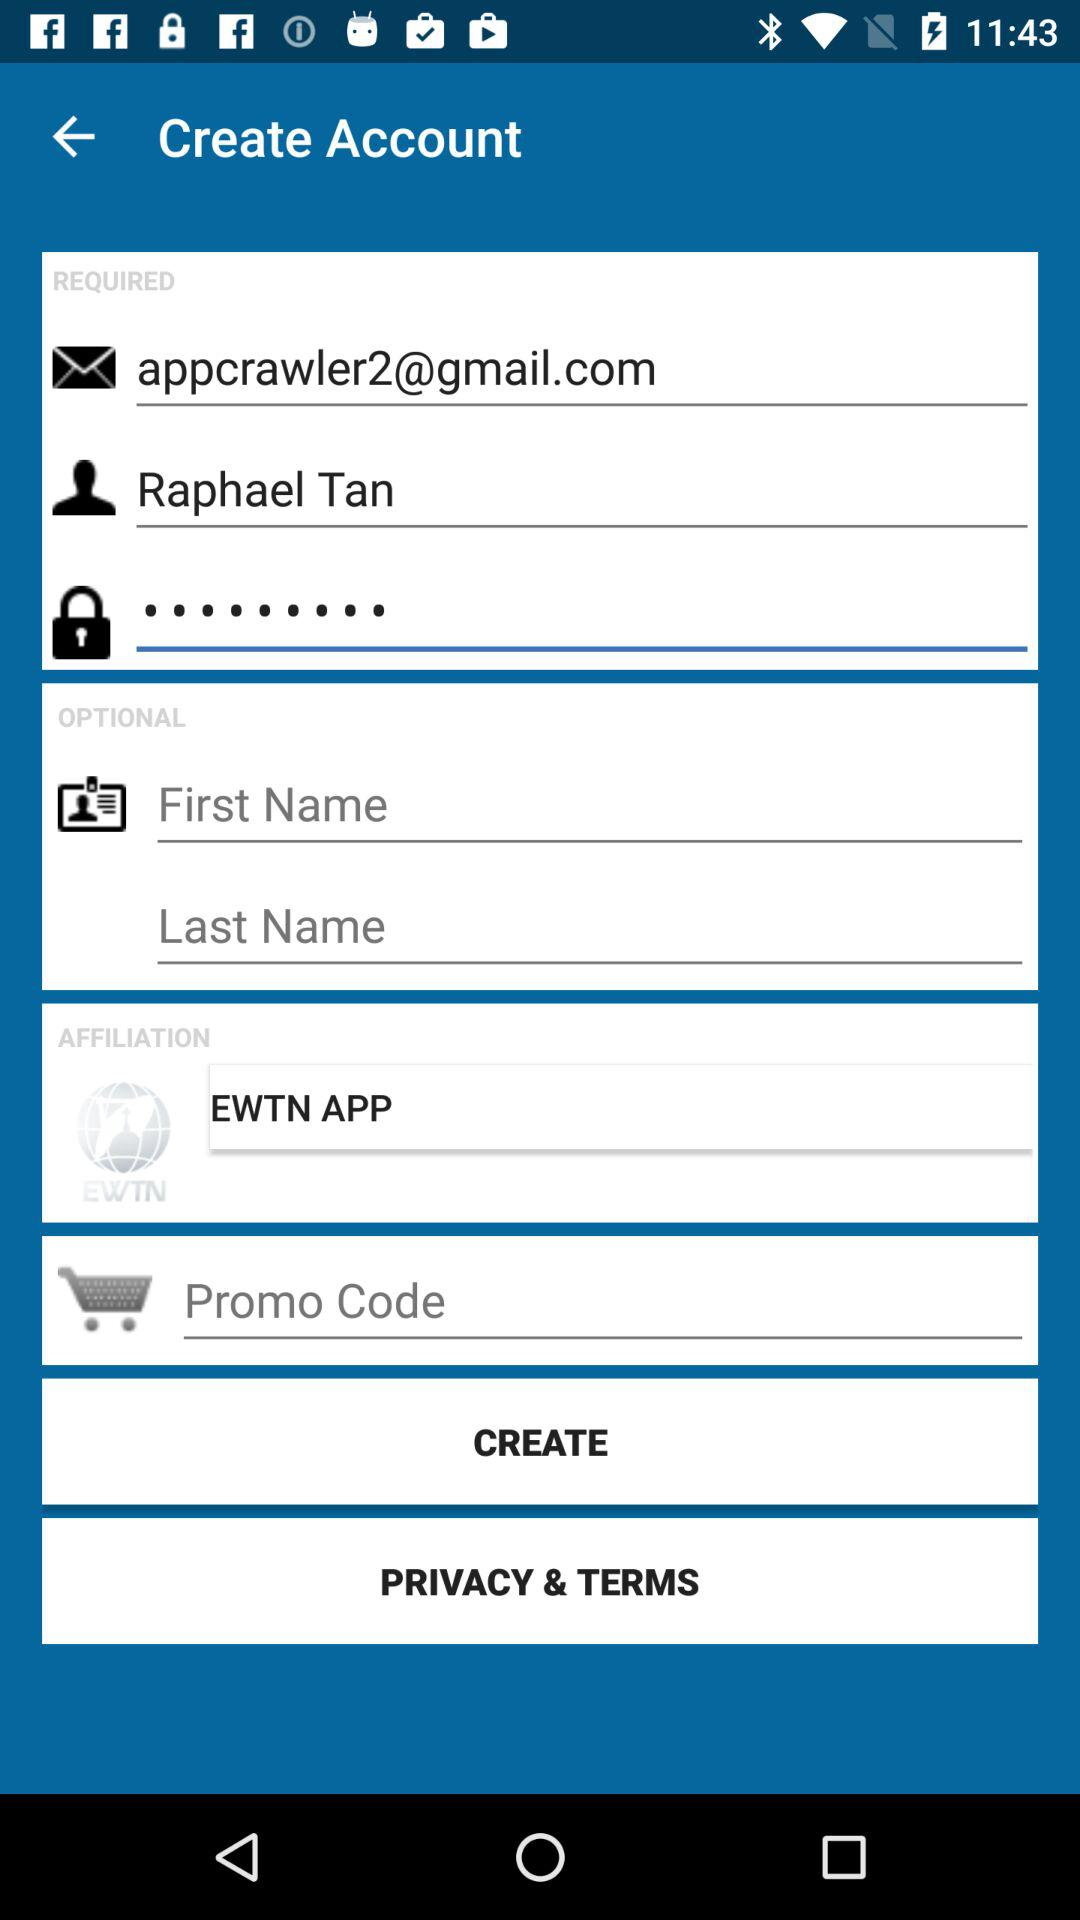What is the user name? The user name is Raphael Tan. 